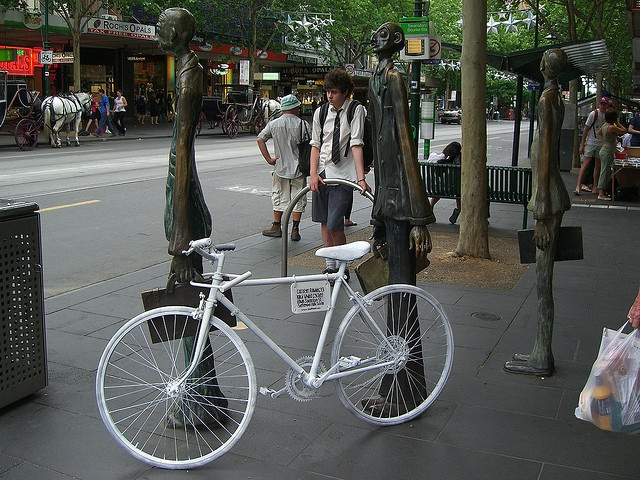Describe the objects in this image and their specific colors. I can see bicycle in black, gray, darkgray, and lightgray tones, people in black, darkgray, gray, and lightgray tones, handbag in black, gray, darkgray, and lightgray tones, people in black, darkgray, gray, and lightgray tones, and bench in black, gray, and darkgray tones in this image. 